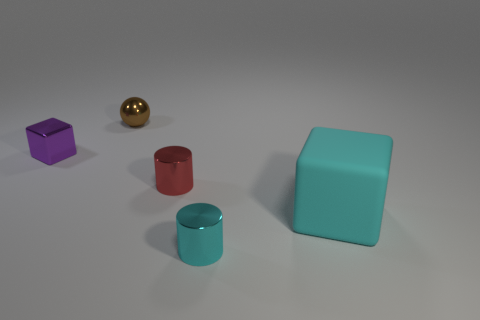Add 1 large cyan rubber things. How many objects exist? 6 Subtract all blocks. How many objects are left? 3 Subtract 0 brown cylinders. How many objects are left? 5 Subtract all metallic balls. Subtract all brown rubber spheres. How many objects are left? 4 Add 5 tiny purple shiny objects. How many tiny purple shiny objects are left? 6 Add 3 small brown metal things. How many small brown metal things exist? 4 